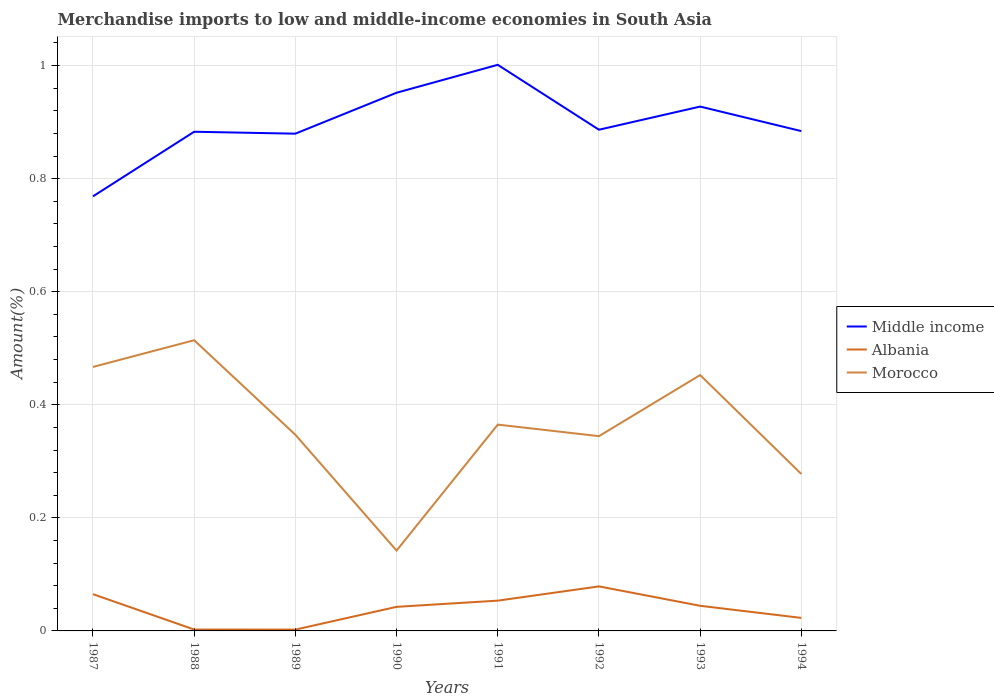How many different coloured lines are there?
Your answer should be compact. 3. Across all years, what is the maximum percentage of amount earned from merchandise imports in Morocco?
Provide a short and direct response. 0.14. In which year was the percentage of amount earned from merchandise imports in Middle income maximum?
Ensure brevity in your answer.  1987. What is the total percentage of amount earned from merchandise imports in Morocco in the graph?
Offer a very short reply. 0.12. What is the difference between the highest and the second highest percentage of amount earned from merchandise imports in Albania?
Your answer should be very brief. 0.08. Is the percentage of amount earned from merchandise imports in Middle income strictly greater than the percentage of amount earned from merchandise imports in Morocco over the years?
Ensure brevity in your answer.  No. How many years are there in the graph?
Offer a very short reply. 8. Are the values on the major ticks of Y-axis written in scientific E-notation?
Keep it short and to the point. No. Does the graph contain any zero values?
Make the answer very short. No. What is the title of the graph?
Your answer should be compact. Merchandise imports to low and middle-income economies in South Asia. Does "Switzerland" appear as one of the legend labels in the graph?
Provide a short and direct response. No. What is the label or title of the X-axis?
Provide a short and direct response. Years. What is the label or title of the Y-axis?
Provide a short and direct response. Amount(%). What is the Amount(%) in Middle income in 1987?
Make the answer very short. 0.77. What is the Amount(%) of Albania in 1987?
Provide a succinct answer. 0.07. What is the Amount(%) in Morocco in 1987?
Your answer should be compact. 0.47. What is the Amount(%) of Middle income in 1988?
Your answer should be very brief. 0.88. What is the Amount(%) in Albania in 1988?
Ensure brevity in your answer.  0. What is the Amount(%) of Morocco in 1988?
Your response must be concise. 0.51. What is the Amount(%) of Middle income in 1989?
Offer a terse response. 0.88. What is the Amount(%) in Albania in 1989?
Your response must be concise. 0. What is the Amount(%) of Morocco in 1989?
Your response must be concise. 0.35. What is the Amount(%) in Middle income in 1990?
Provide a succinct answer. 0.95. What is the Amount(%) in Albania in 1990?
Provide a succinct answer. 0.04. What is the Amount(%) of Morocco in 1990?
Give a very brief answer. 0.14. What is the Amount(%) in Middle income in 1991?
Offer a very short reply. 1. What is the Amount(%) of Albania in 1991?
Your answer should be compact. 0.05. What is the Amount(%) in Morocco in 1991?
Your answer should be compact. 0.36. What is the Amount(%) of Middle income in 1992?
Provide a short and direct response. 0.89. What is the Amount(%) of Albania in 1992?
Keep it short and to the point. 0.08. What is the Amount(%) of Morocco in 1992?
Your answer should be compact. 0.34. What is the Amount(%) of Middle income in 1993?
Provide a short and direct response. 0.93. What is the Amount(%) in Albania in 1993?
Your response must be concise. 0.04. What is the Amount(%) of Morocco in 1993?
Provide a short and direct response. 0.45. What is the Amount(%) in Middle income in 1994?
Make the answer very short. 0.88. What is the Amount(%) of Albania in 1994?
Your response must be concise. 0.02. What is the Amount(%) in Morocco in 1994?
Keep it short and to the point. 0.28. Across all years, what is the maximum Amount(%) of Middle income?
Your answer should be compact. 1. Across all years, what is the maximum Amount(%) in Albania?
Provide a short and direct response. 0.08. Across all years, what is the maximum Amount(%) in Morocco?
Provide a short and direct response. 0.51. Across all years, what is the minimum Amount(%) of Middle income?
Give a very brief answer. 0.77. Across all years, what is the minimum Amount(%) in Albania?
Keep it short and to the point. 0. Across all years, what is the minimum Amount(%) in Morocco?
Make the answer very short. 0.14. What is the total Amount(%) in Middle income in the graph?
Offer a terse response. 7.18. What is the total Amount(%) of Albania in the graph?
Give a very brief answer. 0.31. What is the total Amount(%) in Morocco in the graph?
Keep it short and to the point. 2.91. What is the difference between the Amount(%) in Middle income in 1987 and that in 1988?
Offer a terse response. -0.11. What is the difference between the Amount(%) in Albania in 1987 and that in 1988?
Provide a short and direct response. 0.06. What is the difference between the Amount(%) of Morocco in 1987 and that in 1988?
Provide a succinct answer. -0.05. What is the difference between the Amount(%) of Middle income in 1987 and that in 1989?
Offer a terse response. -0.11. What is the difference between the Amount(%) in Albania in 1987 and that in 1989?
Offer a terse response. 0.06. What is the difference between the Amount(%) in Morocco in 1987 and that in 1989?
Ensure brevity in your answer.  0.12. What is the difference between the Amount(%) of Middle income in 1987 and that in 1990?
Provide a succinct answer. -0.18. What is the difference between the Amount(%) in Albania in 1987 and that in 1990?
Give a very brief answer. 0.02. What is the difference between the Amount(%) of Morocco in 1987 and that in 1990?
Give a very brief answer. 0.32. What is the difference between the Amount(%) in Middle income in 1987 and that in 1991?
Give a very brief answer. -0.23. What is the difference between the Amount(%) of Albania in 1987 and that in 1991?
Your answer should be compact. 0.01. What is the difference between the Amount(%) of Morocco in 1987 and that in 1991?
Offer a very short reply. 0.1. What is the difference between the Amount(%) in Middle income in 1987 and that in 1992?
Provide a succinct answer. -0.12. What is the difference between the Amount(%) of Albania in 1987 and that in 1992?
Provide a succinct answer. -0.01. What is the difference between the Amount(%) in Morocco in 1987 and that in 1992?
Your answer should be compact. 0.12. What is the difference between the Amount(%) of Middle income in 1987 and that in 1993?
Offer a terse response. -0.16. What is the difference between the Amount(%) of Albania in 1987 and that in 1993?
Keep it short and to the point. 0.02. What is the difference between the Amount(%) of Morocco in 1987 and that in 1993?
Your answer should be compact. 0.01. What is the difference between the Amount(%) of Middle income in 1987 and that in 1994?
Ensure brevity in your answer.  -0.12. What is the difference between the Amount(%) of Albania in 1987 and that in 1994?
Your answer should be compact. 0.04. What is the difference between the Amount(%) of Morocco in 1987 and that in 1994?
Your answer should be very brief. 0.19. What is the difference between the Amount(%) in Middle income in 1988 and that in 1989?
Ensure brevity in your answer.  0. What is the difference between the Amount(%) in Albania in 1988 and that in 1989?
Your answer should be compact. 0. What is the difference between the Amount(%) in Morocco in 1988 and that in 1989?
Make the answer very short. 0.17. What is the difference between the Amount(%) in Middle income in 1988 and that in 1990?
Offer a terse response. -0.07. What is the difference between the Amount(%) in Albania in 1988 and that in 1990?
Provide a short and direct response. -0.04. What is the difference between the Amount(%) of Morocco in 1988 and that in 1990?
Make the answer very short. 0.37. What is the difference between the Amount(%) of Middle income in 1988 and that in 1991?
Provide a succinct answer. -0.12. What is the difference between the Amount(%) in Albania in 1988 and that in 1991?
Your response must be concise. -0.05. What is the difference between the Amount(%) of Morocco in 1988 and that in 1991?
Provide a succinct answer. 0.15. What is the difference between the Amount(%) of Middle income in 1988 and that in 1992?
Ensure brevity in your answer.  -0. What is the difference between the Amount(%) in Albania in 1988 and that in 1992?
Provide a succinct answer. -0.08. What is the difference between the Amount(%) of Morocco in 1988 and that in 1992?
Make the answer very short. 0.17. What is the difference between the Amount(%) in Middle income in 1988 and that in 1993?
Provide a short and direct response. -0.04. What is the difference between the Amount(%) of Albania in 1988 and that in 1993?
Ensure brevity in your answer.  -0.04. What is the difference between the Amount(%) in Morocco in 1988 and that in 1993?
Your response must be concise. 0.06. What is the difference between the Amount(%) of Middle income in 1988 and that in 1994?
Provide a succinct answer. -0. What is the difference between the Amount(%) of Albania in 1988 and that in 1994?
Offer a terse response. -0.02. What is the difference between the Amount(%) of Morocco in 1988 and that in 1994?
Keep it short and to the point. 0.24. What is the difference between the Amount(%) in Middle income in 1989 and that in 1990?
Your answer should be compact. -0.07. What is the difference between the Amount(%) of Albania in 1989 and that in 1990?
Provide a succinct answer. -0.04. What is the difference between the Amount(%) in Morocco in 1989 and that in 1990?
Your answer should be very brief. 0.2. What is the difference between the Amount(%) in Middle income in 1989 and that in 1991?
Give a very brief answer. -0.12. What is the difference between the Amount(%) of Albania in 1989 and that in 1991?
Your answer should be very brief. -0.05. What is the difference between the Amount(%) of Morocco in 1989 and that in 1991?
Keep it short and to the point. -0.02. What is the difference between the Amount(%) in Middle income in 1989 and that in 1992?
Provide a succinct answer. -0.01. What is the difference between the Amount(%) in Albania in 1989 and that in 1992?
Make the answer very short. -0.08. What is the difference between the Amount(%) in Morocco in 1989 and that in 1992?
Provide a succinct answer. 0. What is the difference between the Amount(%) of Middle income in 1989 and that in 1993?
Offer a terse response. -0.05. What is the difference between the Amount(%) of Albania in 1989 and that in 1993?
Your answer should be very brief. -0.04. What is the difference between the Amount(%) in Morocco in 1989 and that in 1993?
Give a very brief answer. -0.11. What is the difference between the Amount(%) of Middle income in 1989 and that in 1994?
Keep it short and to the point. -0. What is the difference between the Amount(%) in Albania in 1989 and that in 1994?
Offer a terse response. -0.02. What is the difference between the Amount(%) in Morocco in 1989 and that in 1994?
Offer a terse response. 0.07. What is the difference between the Amount(%) of Middle income in 1990 and that in 1991?
Offer a terse response. -0.05. What is the difference between the Amount(%) of Albania in 1990 and that in 1991?
Offer a very short reply. -0.01. What is the difference between the Amount(%) in Morocco in 1990 and that in 1991?
Provide a short and direct response. -0.22. What is the difference between the Amount(%) in Middle income in 1990 and that in 1992?
Your answer should be very brief. 0.07. What is the difference between the Amount(%) of Albania in 1990 and that in 1992?
Ensure brevity in your answer.  -0.04. What is the difference between the Amount(%) of Morocco in 1990 and that in 1992?
Provide a succinct answer. -0.2. What is the difference between the Amount(%) in Middle income in 1990 and that in 1993?
Ensure brevity in your answer.  0.02. What is the difference between the Amount(%) of Albania in 1990 and that in 1993?
Your answer should be very brief. -0. What is the difference between the Amount(%) of Morocco in 1990 and that in 1993?
Keep it short and to the point. -0.31. What is the difference between the Amount(%) in Middle income in 1990 and that in 1994?
Your response must be concise. 0.07. What is the difference between the Amount(%) of Albania in 1990 and that in 1994?
Offer a very short reply. 0.02. What is the difference between the Amount(%) of Morocco in 1990 and that in 1994?
Your answer should be compact. -0.14. What is the difference between the Amount(%) of Middle income in 1991 and that in 1992?
Your answer should be very brief. 0.11. What is the difference between the Amount(%) of Albania in 1991 and that in 1992?
Provide a succinct answer. -0.03. What is the difference between the Amount(%) in Morocco in 1991 and that in 1992?
Your response must be concise. 0.02. What is the difference between the Amount(%) of Middle income in 1991 and that in 1993?
Make the answer very short. 0.07. What is the difference between the Amount(%) in Albania in 1991 and that in 1993?
Offer a terse response. 0.01. What is the difference between the Amount(%) in Morocco in 1991 and that in 1993?
Your answer should be very brief. -0.09. What is the difference between the Amount(%) in Middle income in 1991 and that in 1994?
Your answer should be very brief. 0.12. What is the difference between the Amount(%) of Albania in 1991 and that in 1994?
Your answer should be compact. 0.03. What is the difference between the Amount(%) in Morocco in 1991 and that in 1994?
Provide a succinct answer. 0.09. What is the difference between the Amount(%) of Middle income in 1992 and that in 1993?
Your answer should be very brief. -0.04. What is the difference between the Amount(%) in Albania in 1992 and that in 1993?
Keep it short and to the point. 0.03. What is the difference between the Amount(%) in Morocco in 1992 and that in 1993?
Ensure brevity in your answer.  -0.11. What is the difference between the Amount(%) in Middle income in 1992 and that in 1994?
Your answer should be compact. 0. What is the difference between the Amount(%) of Albania in 1992 and that in 1994?
Your answer should be compact. 0.06. What is the difference between the Amount(%) in Morocco in 1992 and that in 1994?
Your answer should be compact. 0.07. What is the difference between the Amount(%) of Middle income in 1993 and that in 1994?
Offer a terse response. 0.04. What is the difference between the Amount(%) in Albania in 1993 and that in 1994?
Keep it short and to the point. 0.02. What is the difference between the Amount(%) in Morocco in 1993 and that in 1994?
Offer a very short reply. 0.18. What is the difference between the Amount(%) of Middle income in 1987 and the Amount(%) of Albania in 1988?
Your answer should be very brief. 0.77. What is the difference between the Amount(%) of Middle income in 1987 and the Amount(%) of Morocco in 1988?
Offer a very short reply. 0.25. What is the difference between the Amount(%) of Albania in 1987 and the Amount(%) of Morocco in 1988?
Offer a terse response. -0.45. What is the difference between the Amount(%) in Middle income in 1987 and the Amount(%) in Albania in 1989?
Offer a terse response. 0.77. What is the difference between the Amount(%) of Middle income in 1987 and the Amount(%) of Morocco in 1989?
Your answer should be very brief. 0.42. What is the difference between the Amount(%) of Albania in 1987 and the Amount(%) of Morocco in 1989?
Offer a terse response. -0.28. What is the difference between the Amount(%) of Middle income in 1987 and the Amount(%) of Albania in 1990?
Keep it short and to the point. 0.73. What is the difference between the Amount(%) of Middle income in 1987 and the Amount(%) of Morocco in 1990?
Provide a succinct answer. 0.63. What is the difference between the Amount(%) of Albania in 1987 and the Amount(%) of Morocco in 1990?
Provide a succinct answer. -0.08. What is the difference between the Amount(%) of Middle income in 1987 and the Amount(%) of Albania in 1991?
Your response must be concise. 0.72. What is the difference between the Amount(%) in Middle income in 1987 and the Amount(%) in Morocco in 1991?
Keep it short and to the point. 0.4. What is the difference between the Amount(%) in Albania in 1987 and the Amount(%) in Morocco in 1991?
Ensure brevity in your answer.  -0.3. What is the difference between the Amount(%) in Middle income in 1987 and the Amount(%) in Albania in 1992?
Offer a very short reply. 0.69. What is the difference between the Amount(%) in Middle income in 1987 and the Amount(%) in Morocco in 1992?
Offer a very short reply. 0.42. What is the difference between the Amount(%) of Albania in 1987 and the Amount(%) of Morocco in 1992?
Your answer should be very brief. -0.28. What is the difference between the Amount(%) in Middle income in 1987 and the Amount(%) in Albania in 1993?
Give a very brief answer. 0.72. What is the difference between the Amount(%) of Middle income in 1987 and the Amount(%) of Morocco in 1993?
Provide a short and direct response. 0.32. What is the difference between the Amount(%) of Albania in 1987 and the Amount(%) of Morocco in 1993?
Your answer should be compact. -0.39. What is the difference between the Amount(%) of Middle income in 1987 and the Amount(%) of Albania in 1994?
Keep it short and to the point. 0.75. What is the difference between the Amount(%) in Middle income in 1987 and the Amount(%) in Morocco in 1994?
Your answer should be compact. 0.49. What is the difference between the Amount(%) in Albania in 1987 and the Amount(%) in Morocco in 1994?
Ensure brevity in your answer.  -0.21. What is the difference between the Amount(%) of Middle income in 1988 and the Amount(%) of Albania in 1989?
Your response must be concise. 0.88. What is the difference between the Amount(%) of Middle income in 1988 and the Amount(%) of Morocco in 1989?
Your answer should be compact. 0.54. What is the difference between the Amount(%) of Albania in 1988 and the Amount(%) of Morocco in 1989?
Make the answer very short. -0.34. What is the difference between the Amount(%) of Middle income in 1988 and the Amount(%) of Albania in 1990?
Give a very brief answer. 0.84. What is the difference between the Amount(%) in Middle income in 1988 and the Amount(%) in Morocco in 1990?
Provide a short and direct response. 0.74. What is the difference between the Amount(%) of Albania in 1988 and the Amount(%) of Morocco in 1990?
Give a very brief answer. -0.14. What is the difference between the Amount(%) in Middle income in 1988 and the Amount(%) in Albania in 1991?
Ensure brevity in your answer.  0.83. What is the difference between the Amount(%) in Middle income in 1988 and the Amount(%) in Morocco in 1991?
Ensure brevity in your answer.  0.52. What is the difference between the Amount(%) in Albania in 1988 and the Amount(%) in Morocco in 1991?
Provide a succinct answer. -0.36. What is the difference between the Amount(%) of Middle income in 1988 and the Amount(%) of Albania in 1992?
Offer a very short reply. 0.8. What is the difference between the Amount(%) in Middle income in 1988 and the Amount(%) in Morocco in 1992?
Make the answer very short. 0.54. What is the difference between the Amount(%) of Albania in 1988 and the Amount(%) of Morocco in 1992?
Make the answer very short. -0.34. What is the difference between the Amount(%) of Middle income in 1988 and the Amount(%) of Albania in 1993?
Your response must be concise. 0.84. What is the difference between the Amount(%) in Middle income in 1988 and the Amount(%) in Morocco in 1993?
Your response must be concise. 0.43. What is the difference between the Amount(%) of Albania in 1988 and the Amount(%) of Morocco in 1993?
Offer a terse response. -0.45. What is the difference between the Amount(%) in Middle income in 1988 and the Amount(%) in Albania in 1994?
Make the answer very short. 0.86. What is the difference between the Amount(%) of Middle income in 1988 and the Amount(%) of Morocco in 1994?
Your answer should be compact. 0.61. What is the difference between the Amount(%) in Albania in 1988 and the Amount(%) in Morocco in 1994?
Provide a short and direct response. -0.28. What is the difference between the Amount(%) of Middle income in 1989 and the Amount(%) of Albania in 1990?
Provide a short and direct response. 0.84. What is the difference between the Amount(%) in Middle income in 1989 and the Amount(%) in Morocco in 1990?
Offer a terse response. 0.74. What is the difference between the Amount(%) of Albania in 1989 and the Amount(%) of Morocco in 1990?
Provide a succinct answer. -0.14. What is the difference between the Amount(%) of Middle income in 1989 and the Amount(%) of Albania in 1991?
Offer a very short reply. 0.83. What is the difference between the Amount(%) of Middle income in 1989 and the Amount(%) of Morocco in 1991?
Your answer should be very brief. 0.51. What is the difference between the Amount(%) in Albania in 1989 and the Amount(%) in Morocco in 1991?
Offer a terse response. -0.36. What is the difference between the Amount(%) of Middle income in 1989 and the Amount(%) of Albania in 1992?
Your answer should be compact. 0.8. What is the difference between the Amount(%) in Middle income in 1989 and the Amount(%) in Morocco in 1992?
Make the answer very short. 0.54. What is the difference between the Amount(%) in Albania in 1989 and the Amount(%) in Morocco in 1992?
Your response must be concise. -0.34. What is the difference between the Amount(%) of Middle income in 1989 and the Amount(%) of Albania in 1993?
Ensure brevity in your answer.  0.84. What is the difference between the Amount(%) of Middle income in 1989 and the Amount(%) of Morocco in 1993?
Your answer should be compact. 0.43. What is the difference between the Amount(%) of Albania in 1989 and the Amount(%) of Morocco in 1993?
Make the answer very short. -0.45. What is the difference between the Amount(%) of Middle income in 1989 and the Amount(%) of Albania in 1994?
Offer a very short reply. 0.86. What is the difference between the Amount(%) in Middle income in 1989 and the Amount(%) in Morocco in 1994?
Your response must be concise. 0.6. What is the difference between the Amount(%) in Albania in 1989 and the Amount(%) in Morocco in 1994?
Your answer should be compact. -0.28. What is the difference between the Amount(%) of Middle income in 1990 and the Amount(%) of Albania in 1991?
Ensure brevity in your answer.  0.9. What is the difference between the Amount(%) of Middle income in 1990 and the Amount(%) of Morocco in 1991?
Provide a succinct answer. 0.59. What is the difference between the Amount(%) of Albania in 1990 and the Amount(%) of Morocco in 1991?
Make the answer very short. -0.32. What is the difference between the Amount(%) in Middle income in 1990 and the Amount(%) in Albania in 1992?
Offer a terse response. 0.87. What is the difference between the Amount(%) in Middle income in 1990 and the Amount(%) in Morocco in 1992?
Ensure brevity in your answer.  0.61. What is the difference between the Amount(%) in Albania in 1990 and the Amount(%) in Morocco in 1992?
Your answer should be very brief. -0.3. What is the difference between the Amount(%) of Middle income in 1990 and the Amount(%) of Albania in 1993?
Your answer should be compact. 0.91. What is the difference between the Amount(%) of Middle income in 1990 and the Amount(%) of Morocco in 1993?
Ensure brevity in your answer.  0.5. What is the difference between the Amount(%) in Albania in 1990 and the Amount(%) in Morocco in 1993?
Offer a very short reply. -0.41. What is the difference between the Amount(%) in Middle income in 1990 and the Amount(%) in Albania in 1994?
Make the answer very short. 0.93. What is the difference between the Amount(%) in Middle income in 1990 and the Amount(%) in Morocco in 1994?
Provide a short and direct response. 0.67. What is the difference between the Amount(%) of Albania in 1990 and the Amount(%) of Morocco in 1994?
Make the answer very short. -0.23. What is the difference between the Amount(%) of Middle income in 1991 and the Amount(%) of Albania in 1992?
Offer a terse response. 0.92. What is the difference between the Amount(%) of Middle income in 1991 and the Amount(%) of Morocco in 1992?
Offer a very short reply. 0.66. What is the difference between the Amount(%) in Albania in 1991 and the Amount(%) in Morocco in 1992?
Your response must be concise. -0.29. What is the difference between the Amount(%) of Middle income in 1991 and the Amount(%) of Albania in 1993?
Your answer should be very brief. 0.96. What is the difference between the Amount(%) in Middle income in 1991 and the Amount(%) in Morocco in 1993?
Offer a terse response. 0.55. What is the difference between the Amount(%) in Albania in 1991 and the Amount(%) in Morocco in 1993?
Provide a succinct answer. -0.4. What is the difference between the Amount(%) in Middle income in 1991 and the Amount(%) in Albania in 1994?
Give a very brief answer. 0.98. What is the difference between the Amount(%) in Middle income in 1991 and the Amount(%) in Morocco in 1994?
Give a very brief answer. 0.72. What is the difference between the Amount(%) in Albania in 1991 and the Amount(%) in Morocco in 1994?
Provide a succinct answer. -0.22. What is the difference between the Amount(%) in Middle income in 1992 and the Amount(%) in Albania in 1993?
Your answer should be compact. 0.84. What is the difference between the Amount(%) in Middle income in 1992 and the Amount(%) in Morocco in 1993?
Your response must be concise. 0.43. What is the difference between the Amount(%) in Albania in 1992 and the Amount(%) in Morocco in 1993?
Ensure brevity in your answer.  -0.37. What is the difference between the Amount(%) in Middle income in 1992 and the Amount(%) in Albania in 1994?
Provide a short and direct response. 0.86. What is the difference between the Amount(%) in Middle income in 1992 and the Amount(%) in Morocco in 1994?
Provide a short and direct response. 0.61. What is the difference between the Amount(%) in Albania in 1992 and the Amount(%) in Morocco in 1994?
Your answer should be very brief. -0.2. What is the difference between the Amount(%) in Middle income in 1993 and the Amount(%) in Albania in 1994?
Provide a short and direct response. 0.9. What is the difference between the Amount(%) of Middle income in 1993 and the Amount(%) of Morocco in 1994?
Ensure brevity in your answer.  0.65. What is the difference between the Amount(%) of Albania in 1993 and the Amount(%) of Morocco in 1994?
Ensure brevity in your answer.  -0.23. What is the average Amount(%) in Middle income per year?
Your answer should be very brief. 0.9. What is the average Amount(%) of Albania per year?
Your response must be concise. 0.04. What is the average Amount(%) in Morocco per year?
Your answer should be very brief. 0.36. In the year 1987, what is the difference between the Amount(%) of Middle income and Amount(%) of Albania?
Offer a very short reply. 0.7. In the year 1987, what is the difference between the Amount(%) of Middle income and Amount(%) of Morocco?
Your response must be concise. 0.3. In the year 1987, what is the difference between the Amount(%) in Albania and Amount(%) in Morocco?
Make the answer very short. -0.4. In the year 1988, what is the difference between the Amount(%) in Middle income and Amount(%) in Albania?
Offer a terse response. 0.88. In the year 1988, what is the difference between the Amount(%) in Middle income and Amount(%) in Morocco?
Your response must be concise. 0.37. In the year 1988, what is the difference between the Amount(%) in Albania and Amount(%) in Morocco?
Give a very brief answer. -0.51. In the year 1989, what is the difference between the Amount(%) in Middle income and Amount(%) in Albania?
Your answer should be very brief. 0.88. In the year 1989, what is the difference between the Amount(%) in Middle income and Amount(%) in Morocco?
Your answer should be very brief. 0.53. In the year 1989, what is the difference between the Amount(%) of Albania and Amount(%) of Morocco?
Provide a short and direct response. -0.34. In the year 1990, what is the difference between the Amount(%) in Middle income and Amount(%) in Albania?
Your response must be concise. 0.91. In the year 1990, what is the difference between the Amount(%) of Middle income and Amount(%) of Morocco?
Make the answer very short. 0.81. In the year 1990, what is the difference between the Amount(%) of Albania and Amount(%) of Morocco?
Make the answer very short. -0.1. In the year 1991, what is the difference between the Amount(%) of Middle income and Amount(%) of Albania?
Provide a short and direct response. 0.95. In the year 1991, what is the difference between the Amount(%) in Middle income and Amount(%) in Morocco?
Keep it short and to the point. 0.64. In the year 1991, what is the difference between the Amount(%) in Albania and Amount(%) in Morocco?
Make the answer very short. -0.31. In the year 1992, what is the difference between the Amount(%) in Middle income and Amount(%) in Albania?
Make the answer very short. 0.81. In the year 1992, what is the difference between the Amount(%) in Middle income and Amount(%) in Morocco?
Make the answer very short. 0.54. In the year 1992, what is the difference between the Amount(%) of Albania and Amount(%) of Morocco?
Your answer should be compact. -0.27. In the year 1993, what is the difference between the Amount(%) of Middle income and Amount(%) of Albania?
Your answer should be compact. 0.88. In the year 1993, what is the difference between the Amount(%) of Middle income and Amount(%) of Morocco?
Give a very brief answer. 0.47. In the year 1993, what is the difference between the Amount(%) in Albania and Amount(%) in Morocco?
Offer a very short reply. -0.41. In the year 1994, what is the difference between the Amount(%) of Middle income and Amount(%) of Albania?
Ensure brevity in your answer.  0.86. In the year 1994, what is the difference between the Amount(%) in Middle income and Amount(%) in Morocco?
Offer a very short reply. 0.61. In the year 1994, what is the difference between the Amount(%) in Albania and Amount(%) in Morocco?
Offer a terse response. -0.25. What is the ratio of the Amount(%) in Middle income in 1987 to that in 1988?
Make the answer very short. 0.87. What is the ratio of the Amount(%) in Albania in 1987 to that in 1988?
Your response must be concise. 26.4. What is the ratio of the Amount(%) of Morocco in 1987 to that in 1988?
Your response must be concise. 0.91. What is the ratio of the Amount(%) in Middle income in 1987 to that in 1989?
Ensure brevity in your answer.  0.87. What is the ratio of the Amount(%) in Albania in 1987 to that in 1989?
Provide a succinct answer. 27.7. What is the ratio of the Amount(%) of Morocco in 1987 to that in 1989?
Your response must be concise. 1.35. What is the ratio of the Amount(%) of Middle income in 1987 to that in 1990?
Offer a very short reply. 0.81. What is the ratio of the Amount(%) of Albania in 1987 to that in 1990?
Provide a succinct answer. 1.53. What is the ratio of the Amount(%) in Morocco in 1987 to that in 1990?
Make the answer very short. 3.29. What is the ratio of the Amount(%) in Middle income in 1987 to that in 1991?
Ensure brevity in your answer.  0.77. What is the ratio of the Amount(%) in Albania in 1987 to that in 1991?
Your response must be concise. 1.21. What is the ratio of the Amount(%) of Morocco in 1987 to that in 1991?
Your answer should be compact. 1.28. What is the ratio of the Amount(%) of Middle income in 1987 to that in 1992?
Give a very brief answer. 0.87. What is the ratio of the Amount(%) of Albania in 1987 to that in 1992?
Provide a short and direct response. 0.83. What is the ratio of the Amount(%) in Morocco in 1987 to that in 1992?
Make the answer very short. 1.36. What is the ratio of the Amount(%) in Middle income in 1987 to that in 1993?
Make the answer very short. 0.83. What is the ratio of the Amount(%) of Albania in 1987 to that in 1993?
Provide a succinct answer. 1.46. What is the ratio of the Amount(%) of Morocco in 1987 to that in 1993?
Make the answer very short. 1.03. What is the ratio of the Amount(%) of Middle income in 1987 to that in 1994?
Keep it short and to the point. 0.87. What is the ratio of the Amount(%) of Albania in 1987 to that in 1994?
Ensure brevity in your answer.  2.82. What is the ratio of the Amount(%) of Morocco in 1987 to that in 1994?
Your response must be concise. 1.68. What is the ratio of the Amount(%) in Middle income in 1988 to that in 1989?
Offer a terse response. 1. What is the ratio of the Amount(%) of Albania in 1988 to that in 1989?
Offer a terse response. 1.05. What is the ratio of the Amount(%) of Morocco in 1988 to that in 1989?
Provide a short and direct response. 1.48. What is the ratio of the Amount(%) in Middle income in 1988 to that in 1990?
Offer a very short reply. 0.93. What is the ratio of the Amount(%) of Albania in 1988 to that in 1990?
Give a very brief answer. 0.06. What is the ratio of the Amount(%) of Morocco in 1988 to that in 1990?
Your answer should be compact. 3.62. What is the ratio of the Amount(%) of Middle income in 1988 to that in 1991?
Your answer should be very brief. 0.88. What is the ratio of the Amount(%) of Albania in 1988 to that in 1991?
Offer a terse response. 0.05. What is the ratio of the Amount(%) of Morocco in 1988 to that in 1991?
Your response must be concise. 1.41. What is the ratio of the Amount(%) in Middle income in 1988 to that in 1992?
Ensure brevity in your answer.  1. What is the ratio of the Amount(%) of Albania in 1988 to that in 1992?
Make the answer very short. 0.03. What is the ratio of the Amount(%) of Morocco in 1988 to that in 1992?
Your answer should be compact. 1.49. What is the ratio of the Amount(%) of Middle income in 1988 to that in 1993?
Offer a terse response. 0.95. What is the ratio of the Amount(%) of Albania in 1988 to that in 1993?
Keep it short and to the point. 0.06. What is the ratio of the Amount(%) of Morocco in 1988 to that in 1993?
Give a very brief answer. 1.14. What is the ratio of the Amount(%) of Middle income in 1988 to that in 1994?
Your response must be concise. 1. What is the ratio of the Amount(%) in Albania in 1988 to that in 1994?
Keep it short and to the point. 0.11. What is the ratio of the Amount(%) in Morocco in 1988 to that in 1994?
Offer a terse response. 1.85. What is the ratio of the Amount(%) in Middle income in 1989 to that in 1990?
Your answer should be very brief. 0.92. What is the ratio of the Amount(%) of Albania in 1989 to that in 1990?
Offer a very short reply. 0.06. What is the ratio of the Amount(%) in Morocco in 1989 to that in 1990?
Give a very brief answer. 2.44. What is the ratio of the Amount(%) of Middle income in 1989 to that in 1991?
Offer a very short reply. 0.88. What is the ratio of the Amount(%) of Albania in 1989 to that in 1991?
Offer a terse response. 0.04. What is the ratio of the Amount(%) of Morocco in 1989 to that in 1991?
Your answer should be compact. 0.95. What is the ratio of the Amount(%) in Albania in 1989 to that in 1992?
Offer a very short reply. 0.03. What is the ratio of the Amount(%) of Morocco in 1989 to that in 1992?
Your answer should be very brief. 1.01. What is the ratio of the Amount(%) of Middle income in 1989 to that in 1993?
Ensure brevity in your answer.  0.95. What is the ratio of the Amount(%) in Albania in 1989 to that in 1993?
Offer a very short reply. 0.05. What is the ratio of the Amount(%) in Morocco in 1989 to that in 1993?
Your answer should be compact. 0.77. What is the ratio of the Amount(%) in Middle income in 1989 to that in 1994?
Ensure brevity in your answer.  0.99. What is the ratio of the Amount(%) in Albania in 1989 to that in 1994?
Provide a succinct answer. 0.1. What is the ratio of the Amount(%) of Morocco in 1989 to that in 1994?
Your answer should be very brief. 1.25. What is the ratio of the Amount(%) in Middle income in 1990 to that in 1991?
Your response must be concise. 0.95. What is the ratio of the Amount(%) in Albania in 1990 to that in 1991?
Provide a short and direct response. 0.8. What is the ratio of the Amount(%) in Morocco in 1990 to that in 1991?
Provide a short and direct response. 0.39. What is the ratio of the Amount(%) in Middle income in 1990 to that in 1992?
Your answer should be very brief. 1.07. What is the ratio of the Amount(%) in Albania in 1990 to that in 1992?
Your answer should be very brief. 0.54. What is the ratio of the Amount(%) of Morocco in 1990 to that in 1992?
Your response must be concise. 0.41. What is the ratio of the Amount(%) in Middle income in 1990 to that in 1993?
Make the answer very short. 1.03. What is the ratio of the Amount(%) in Albania in 1990 to that in 1993?
Provide a succinct answer. 0.96. What is the ratio of the Amount(%) in Morocco in 1990 to that in 1993?
Offer a terse response. 0.31. What is the ratio of the Amount(%) of Middle income in 1990 to that in 1994?
Offer a terse response. 1.08. What is the ratio of the Amount(%) of Albania in 1990 to that in 1994?
Offer a terse response. 1.85. What is the ratio of the Amount(%) of Morocco in 1990 to that in 1994?
Provide a succinct answer. 0.51. What is the ratio of the Amount(%) in Middle income in 1991 to that in 1992?
Offer a very short reply. 1.13. What is the ratio of the Amount(%) in Albania in 1991 to that in 1992?
Provide a short and direct response. 0.68. What is the ratio of the Amount(%) in Morocco in 1991 to that in 1992?
Your answer should be very brief. 1.06. What is the ratio of the Amount(%) of Middle income in 1991 to that in 1993?
Give a very brief answer. 1.08. What is the ratio of the Amount(%) of Albania in 1991 to that in 1993?
Offer a terse response. 1.21. What is the ratio of the Amount(%) in Morocco in 1991 to that in 1993?
Provide a short and direct response. 0.81. What is the ratio of the Amount(%) of Middle income in 1991 to that in 1994?
Ensure brevity in your answer.  1.13. What is the ratio of the Amount(%) of Albania in 1991 to that in 1994?
Provide a succinct answer. 2.33. What is the ratio of the Amount(%) in Morocco in 1991 to that in 1994?
Make the answer very short. 1.31. What is the ratio of the Amount(%) in Middle income in 1992 to that in 1993?
Your response must be concise. 0.96. What is the ratio of the Amount(%) of Albania in 1992 to that in 1993?
Offer a very short reply. 1.77. What is the ratio of the Amount(%) of Morocco in 1992 to that in 1993?
Keep it short and to the point. 0.76. What is the ratio of the Amount(%) in Albania in 1992 to that in 1994?
Your answer should be very brief. 3.42. What is the ratio of the Amount(%) in Morocco in 1992 to that in 1994?
Your answer should be compact. 1.24. What is the ratio of the Amount(%) of Middle income in 1993 to that in 1994?
Provide a succinct answer. 1.05. What is the ratio of the Amount(%) of Albania in 1993 to that in 1994?
Keep it short and to the point. 1.93. What is the ratio of the Amount(%) in Morocco in 1993 to that in 1994?
Give a very brief answer. 1.63. What is the difference between the highest and the second highest Amount(%) of Middle income?
Your answer should be very brief. 0.05. What is the difference between the highest and the second highest Amount(%) of Albania?
Your answer should be very brief. 0.01. What is the difference between the highest and the second highest Amount(%) of Morocco?
Offer a terse response. 0.05. What is the difference between the highest and the lowest Amount(%) in Middle income?
Provide a succinct answer. 0.23. What is the difference between the highest and the lowest Amount(%) of Albania?
Ensure brevity in your answer.  0.08. What is the difference between the highest and the lowest Amount(%) in Morocco?
Offer a terse response. 0.37. 